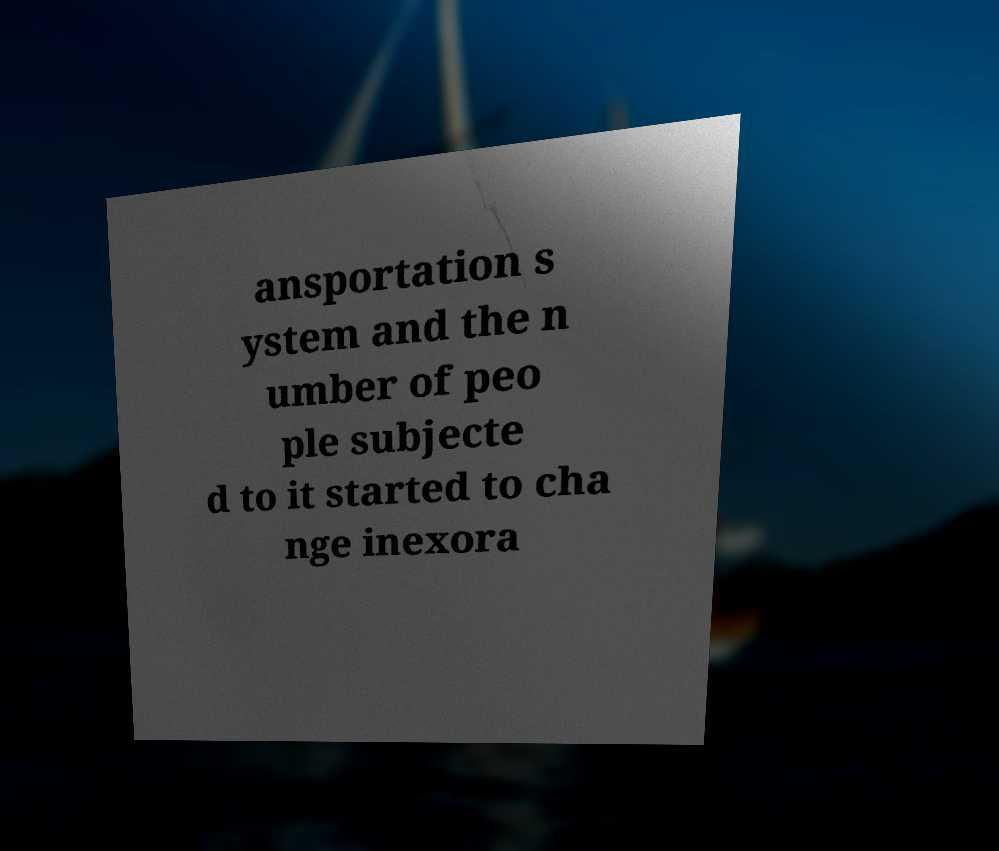What messages or text are displayed in this image? I need them in a readable, typed format. ansportation s ystem and the n umber of peo ple subjecte d to it started to cha nge inexora 